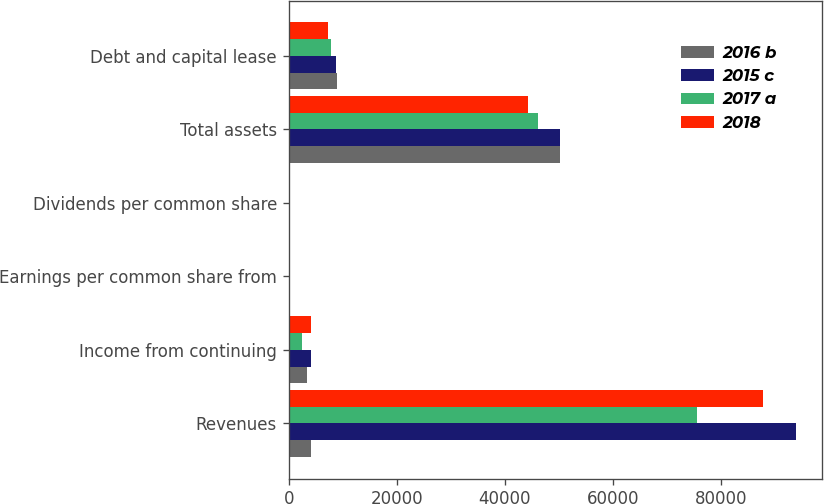Convert chart to OTSL. <chart><loc_0><loc_0><loc_500><loc_500><stacked_bar_chart><ecel><fcel>Revenues<fcel>Income from continuing<fcel>Earnings per common share from<fcel>Dividends per common share<fcel>Total assets<fcel>Debt and capital lease<nl><fcel>2016 b<fcel>4156<fcel>3353<fcel>7.29<fcel>3.2<fcel>50155<fcel>8871<nl><fcel>2015 c<fcel>93980<fcel>4156<fcel>9.16<fcel>2.8<fcel>50158<fcel>8750<nl><fcel>2017 a<fcel>75659<fcel>2417<fcel>4.94<fcel>2.4<fcel>46173<fcel>7886<nl><fcel>2018<fcel>87804<fcel>4101<fcel>7.99<fcel>1.7<fcel>44227<fcel>7208<nl></chart> 